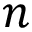<formula> <loc_0><loc_0><loc_500><loc_500>n</formula> 